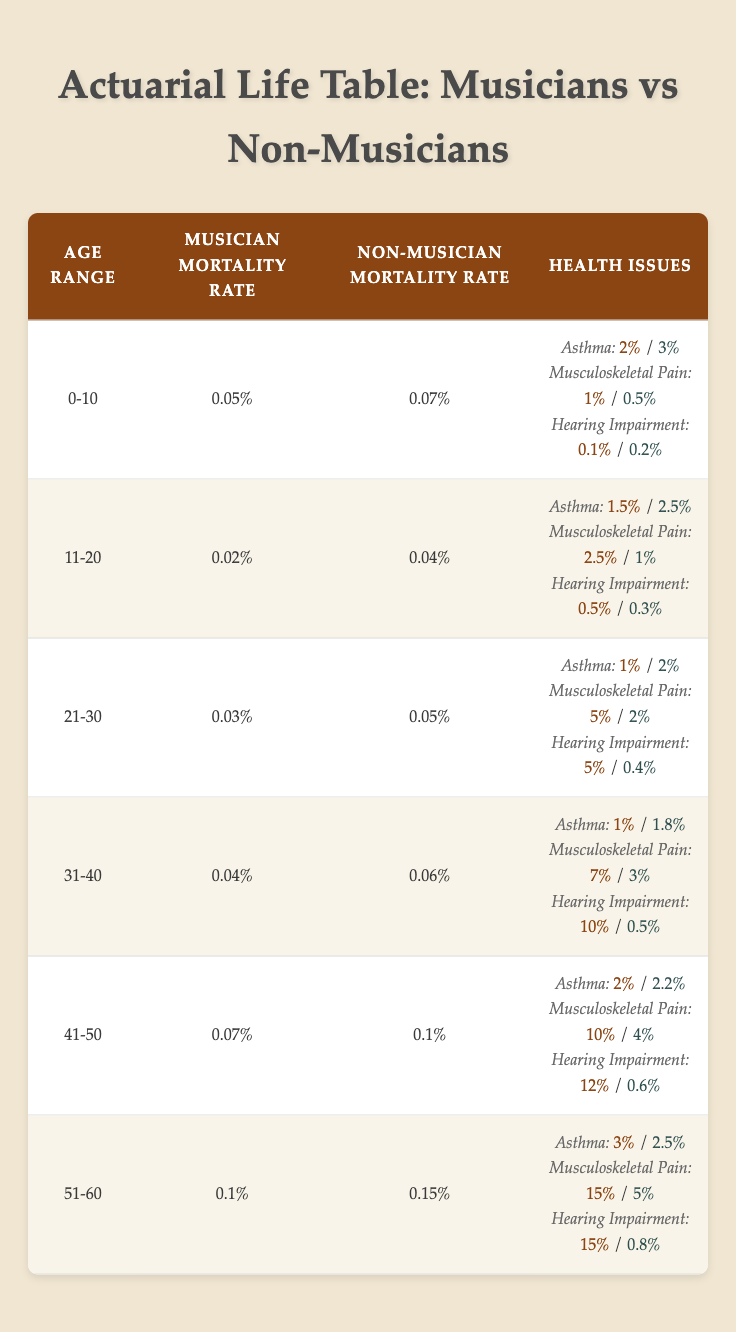What is the musician mortality rate for the age group 41-50? By looking at the table under the "Musician Mortality Rate" for the age range "41-50", we see the value listed is 0.0007.
Answer: 0.0007 What is the percentage of asthma in musicians aged 31-40? The table specifies that for the age group "31-40", the percentage of asthma in musicians is 0.01 (or 1%).
Answer: 1% Which age group shows the highest rate of musculoskeletal pain in musicians? By comparing the values for musculoskeletal pain across all age groups, the highest value is found in the "51-60" age group, which shows a rate of 0.15 (or 15%).
Answer: 51-60 What is the difference in the percentage of hearing impairment between musicians and non-musicians in the 21-30 age group? The musician percentage for hearing impairment in the "21-30" age group is 0.05 (or 5%) and the non-musician percentage is 0.004 (or 0.4%). The difference is calculated as 0.05 - 0.004 = 0.046, or 4.6%.
Answer: 4.6% Are musicians aged 41-50 less likely to report asthma than non-musicians in the same age group? For the age range "41-50", musicians have an asthma rate of 0.02 (2%), while non-musicians have a rate of 0.022 (2.2%). Since 2% is less than 2.2%, the statement is true.
Answer: Yes What is the average mortality rate for musicians in the age groups 31-40 and 51-60? The musician mortality rates for the specified age groups are 0.0004 for 31-40 and 0.001 for 51-60. The average is calculated as (0.0004 + 0.001) / 2 = 0.0007.
Answer: 0.0007 Which health issue has the highest prevalence among non-musicians in the age group 41-50? For the age group "41-50", the non-musician health issues indicate that musculoskeletal pain has the highest prevalence at 0.04 (or 4%) compared to other health issues.
Answer: Musculoskeletal Pain What are the rates of hearing impairment for musicians and non-musicians in the age bracket of 51-60? According to the table, musicians aged 51-60 have a hearing impairment rate of 0.15 (or 15%), while non-musicians have a rate of 0.008 (or 0.8%).
Answer: 0.15 (musicians), 0.008 (non-musicians) Do musicians experience a lower mortality rate compared to non-musicians at age 21-30? Given that the musician mortality rate for age 21-30 is 0.0003 and the non-musician rate is 0.0005, we can conclude that musicians do have a lower mortality rate in this group.
Answer: Yes 